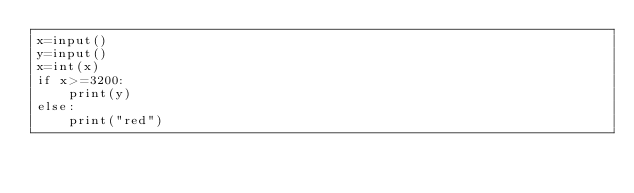<code> <loc_0><loc_0><loc_500><loc_500><_Python_>x=input()
y=input()
x=int(x)
if x>=3200:
    print(y)
else:
    print("red")</code> 